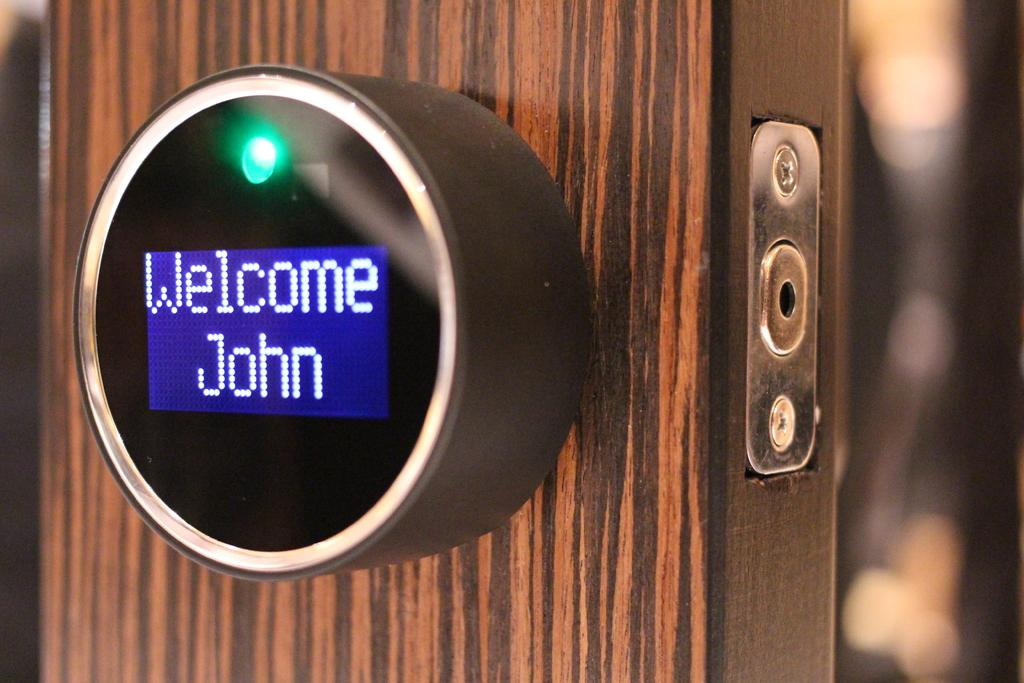Provide a one-sentence caption for the provided image. a round smart device on a door reading Welcome John. 